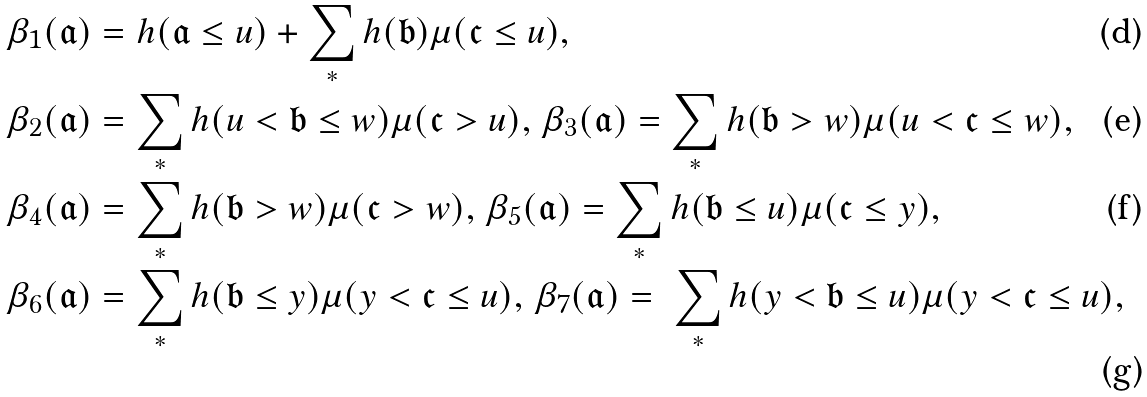<formula> <loc_0><loc_0><loc_500><loc_500>\beta _ { 1 } ( \mathfrak { a } ) & = h ( \mathfrak { a } \leq u ) + \sum _ { * } h ( \mathfrak { b } ) \mu ( \mathfrak { c } \leq u ) , \\ \beta _ { 2 } ( \mathfrak { a } ) & = \sum _ { * } h ( u < \mathfrak { b } \leq w ) \mu ( \mathfrak { c } > u ) , \, \beta _ { 3 } ( \mathfrak { a } ) = \sum _ { * } h ( \mathfrak { b } > w ) \mu ( u < \mathfrak { c } \leq w ) , \\ \beta _ { 4 } ( \mathfrak { a } ) & = \sum _ { * } h ( \mathfrak { b } > w ) \mu ( \mathfrak { c } > w ) , \, \beta _ { 5 } ( \mathfrak { a } ) = \sum _ { * } h ( \mathfrak { b } \leq u ) \mu ( \mathfrak { c } \leq y ) , \\ \beta _ { 6 } ( \mathfrak { a } ) & = \sum _ { * } h ( \mathfrak { b } \leq y ) \mu ( y < \mathfrak { c } \leq u ) , \, \beta _ { 7 } ( \mathfrak { a } ) = \ \sum _ { * } h ( y < \mathfrak { b } \leq u ) \mu ( y < \mathfrak { c } \leq u ) ,</formula> 